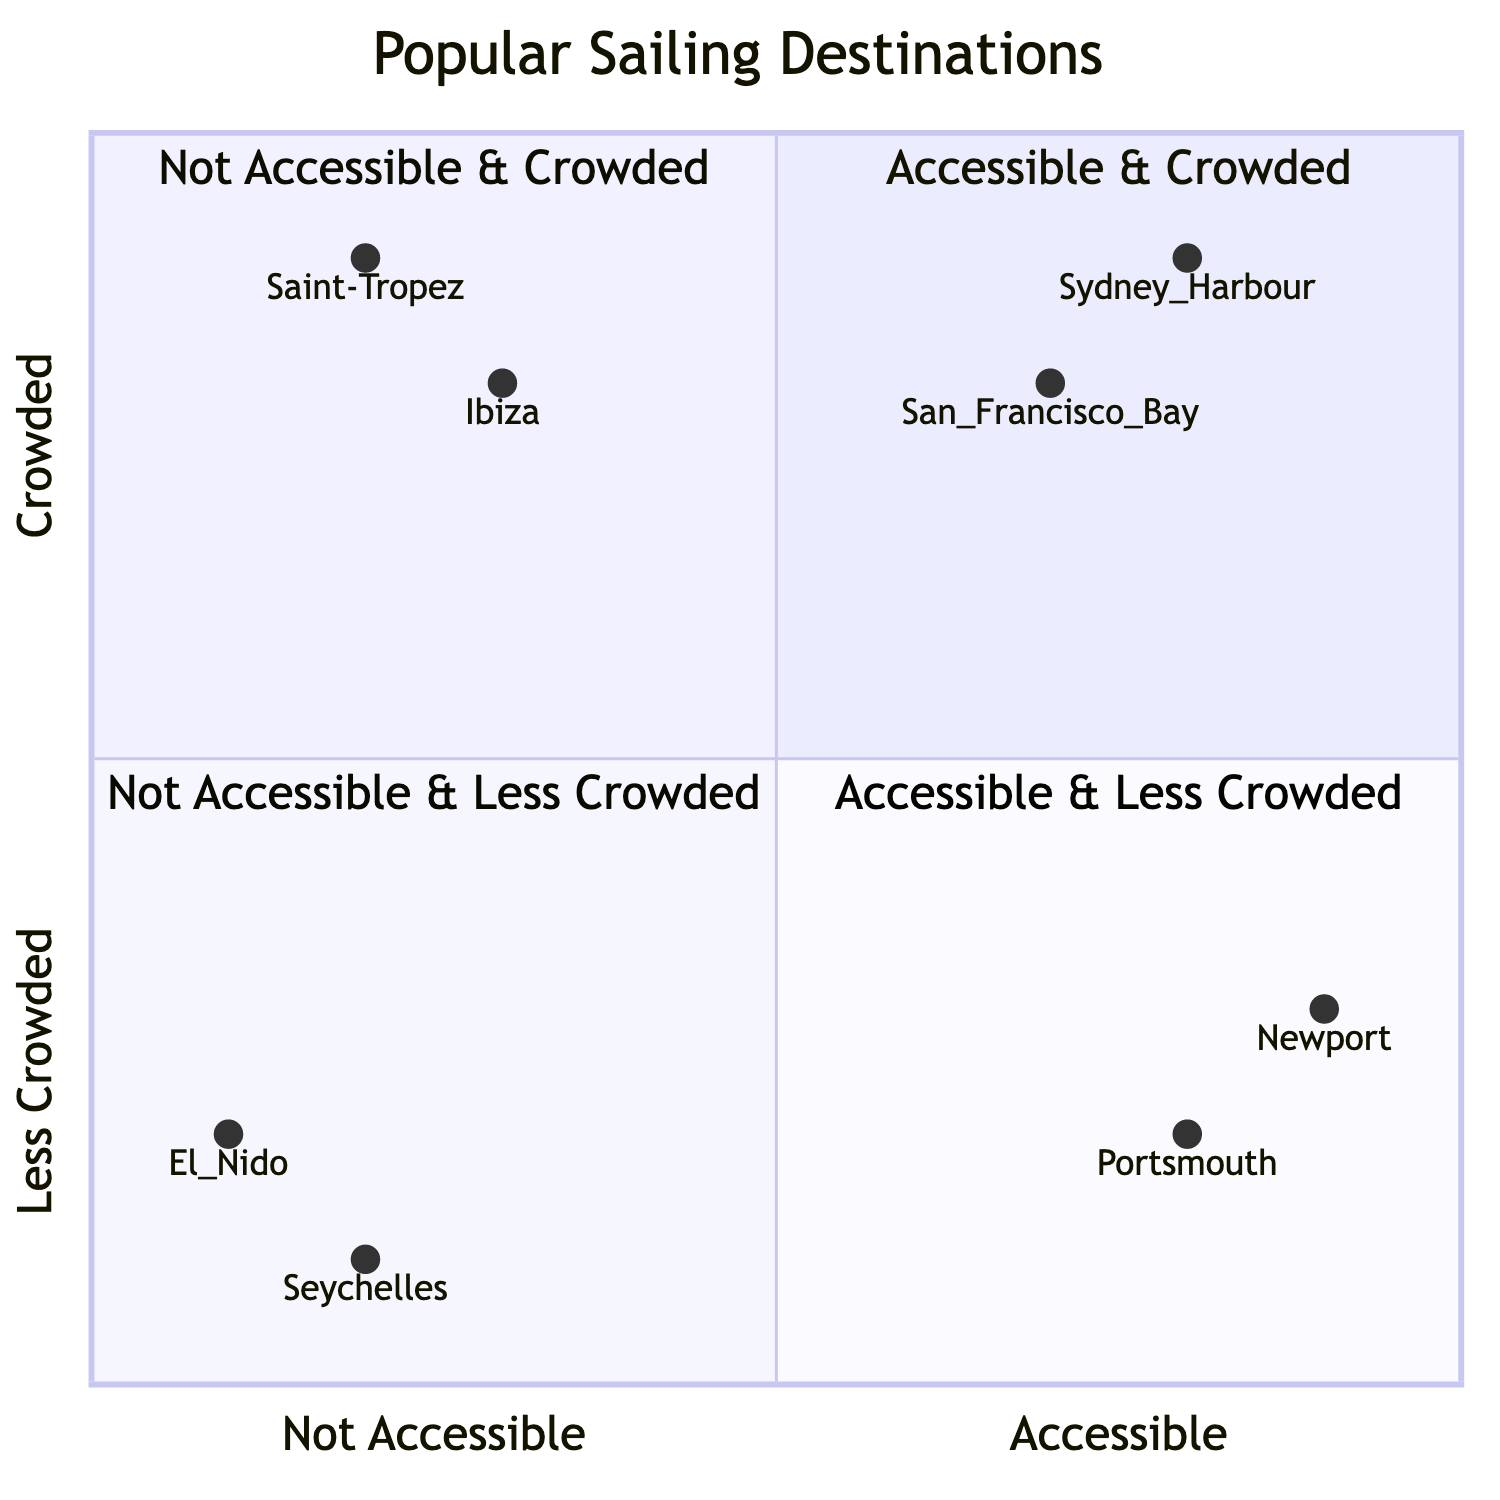What are the two destinations categorized as Accessible & Crowded? According to the quadrant chart, the destinations that fall into the "Accessible & Crowded" category are Sydney Harbour, Australia and San Francisco Bay, USA. These locations are both located in the upper-left quadrant of the chart.
Answer: Sydney Harbour, San Francisco Bay Which destination is the least accessible and less crowded? The destination that is classified as "Not Accessible & Less Crowded" on the quadrant chart is El Nido, Philippines. It occupies a position in the lower-right quadrant, indicating both low accessibility and low crowd levels.
Answer: El Nido How many destinations are classified as Accessible yet crowded? In the quadrant chart, there are two destinations that are categorized as "Accessible & Crowded," which are Sydney Harbour and San Francisco Bay. Therefore, the total count of these destinations is two.
Answer: 2 What does the position of Newport, Rhode Island indicate about its accessibility and crowd level? Newport, Rhode Island is located in the "Accessible & Less Crowded" quadrant of the chart. This indicates that it has good accessibility features and lower crowd levels compared to other destinations.
Answer: Accessible & Less Crowded Which destination is categorized as Not Accessible yet Crowded? The destinations that fall under the "Not Accessible & Crowded" category in the quadrant chart are Saint-Tropez, France and Ibiza, Spain. Both these locations are found in the upper-right quadrant.
Answer: Saint-Tropez, Ibiza What is the accessibility situation for Seychelles, according to the chart? Seychelles is classified as "Not Accessible & Less Crowded" in the quadrant chart. This indicates that it has limited accessibility features and is not heavily crowded.
Answer: Not Accessible & Less Crowded Which destination ranks highest in accessibility among all listed? Newport, Rhode Island is ranked highest in accessibility among the listed destinations, located in the quadrant "Accessible & Less Crowded." It is positioned farthest to the right in the accessible category.
Answer: Newport, Rhode Island How many destinations fall into the Not Accessible & Crowded quadrant? There are two destinations categorized as "Not Accessible & Crowded," which are Saint-Tropez and Ibiza, indicating that both are popular but lack accessibility features.
Answer: 2 